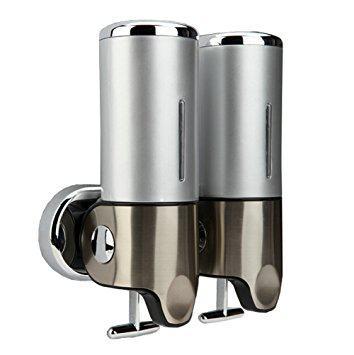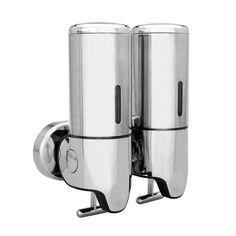The first image is the image on the left, the second image is the image on the right. Evaluate the accuracy of this statement regarding the images: "One image shows a cylindrical dispenser with a pump top and nozzle.". Is it true? Answer yes or no. No. The first image is the image on the left, the second image is the image on the right. For the images displayed, is the sentence "A dispenser has a spout coming out from the top." factually correct? Answer yes or no. No. 